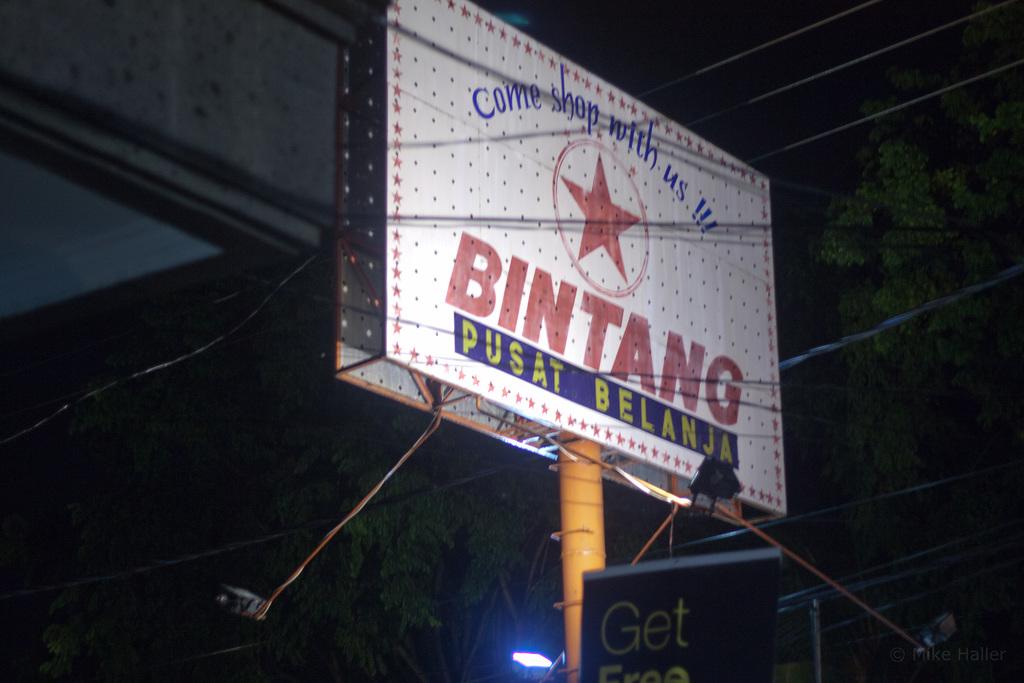What store is advertised on the billboard?
Your answer should be compact. Bintang. What does it say above the star?
Provide a succinct answer. Come shop with us. 